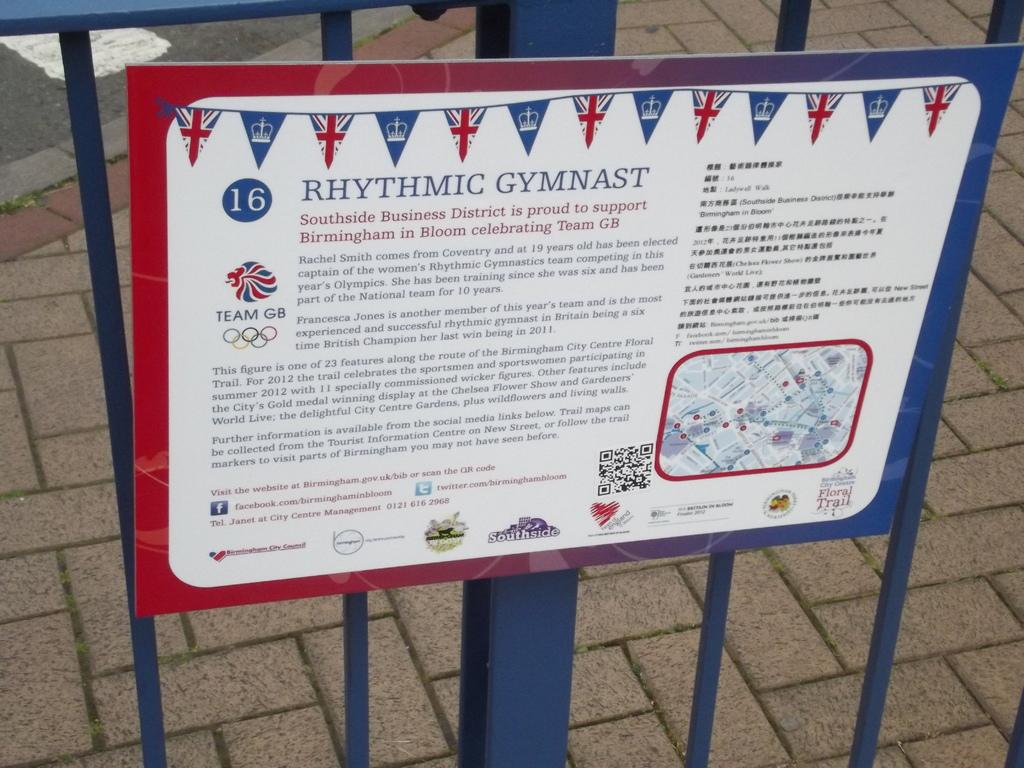<image>
Offer a succinct explanation of the picture presented. A sign on a fence shows support for rhythmic gymnast Rachel Smith. 